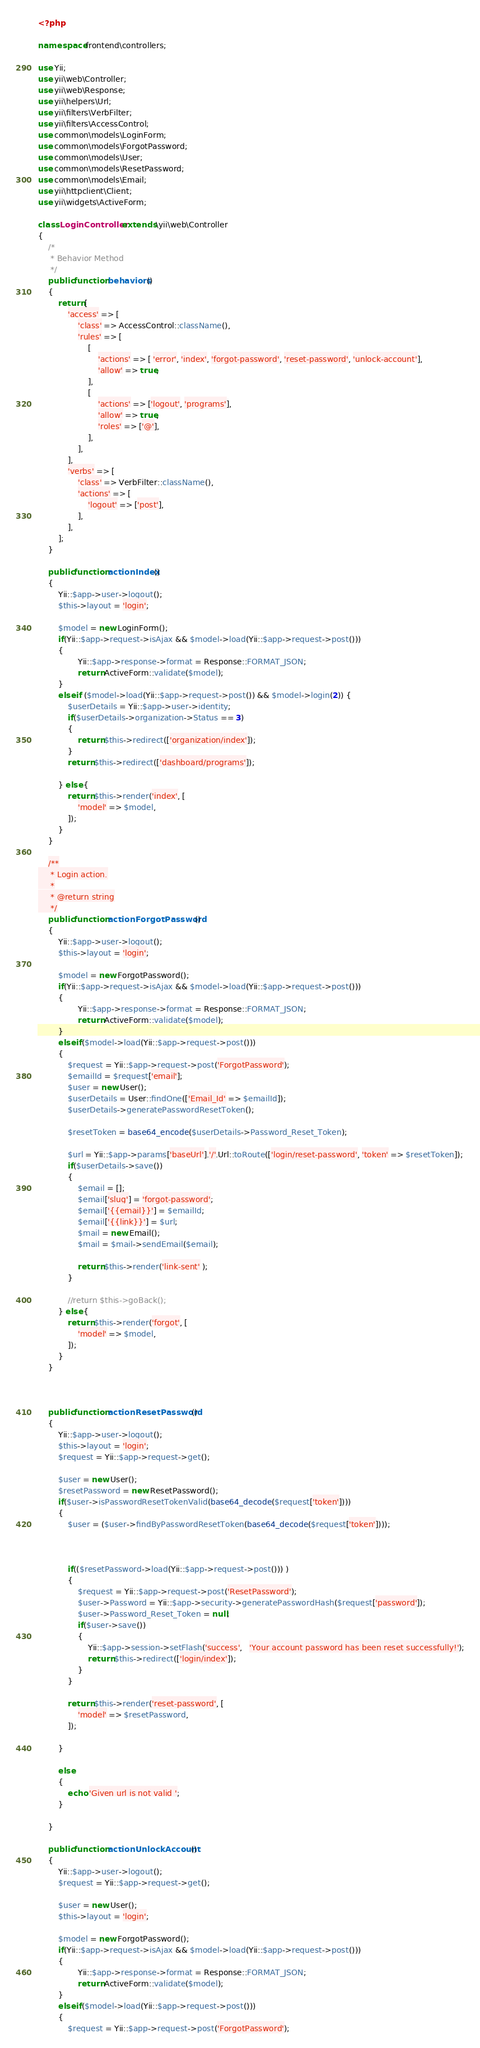Convert code to text. <code><loc_0><loc_0><loc_500><loc_500><_PHP_><?php

namespace frontend\controllers;

use Yii;
use yii\web\Controller;
use yii\web\Response;
use yii\helpers\Url;
use yii\filters\VerbFilter;
use yii\filters\AccessControl;
use common\models\LoginForm;
use common\models\ForgotPassword;
use common\models\User;
use common\models\ResetPassword;
use common\models\Email;
use yii\httpclient\Client;
use yii\widgets\ActiveForm;

class LoginController extends \yii\web\Controller
{
    /*
     * Behavior Method
     */
    public function behaviors()
    {
        return [
            'access' => [
                'class' => AccessControl::className(),
                'rules' => [
                    [
                        'actions' => [ 'error', 'index', 'forgot-password', 'reset-password', 'unlock-account'],
                        'allow' => true,
                    ],
                    [
                        'actions' => ['logout', 'programs'],
                        'allow' => true,
                        'roles' => ['@'],
                    ],
                ],
            ],
            'verbs' => [
                'class' => VerbFilter::className(),
                'actions' => [
                    'logout' => ['post'],
                ],
            ],
        ];
    }
    
    public function actionIndex()
    {
        Yii::$app->user->logout();
        $this->layout = 'login';
        
        $model = new LoginForm();
        if(Yii::$app->request->isAjax && $model->load(Yii::$app->request->post()))
        {
                Yii::$app->response->format = Response::FORMAT_JSON;
                return ActiveForm::validate($model);
        } 
        else if ($model->load(Yii::$app->request->post()) && $model->login(2)) {  
            $userDetails = Yii::$app->user->identity;
            if($userDetails->organization->Status == 3)
            {
                return $this->redirect(['organization/index']);
            }
            return $this->redirect(['dashboard/programs']);

        } else {
            return $this->render('index', [
                'model' => $model,
            ]);
        }
    }
    
    /**
     * Login action.
     *
     * @return string
     */
    public function actionForgotPassword()
    {
        Yii::$app->user->logout();
        $this->layout = 'login';
        
        $model = new ForgotPassword();
        if(Yii::$app->request->isAjax && $model->load(Yii::$app->request->post()))
        {
                Yii::$app->response->format = Response::FORMAT_JSON;
                return ActiveForm::validate($model);
        } 
        elseif ($model->load(Yii::$app->request->post())) 
        {
            $request = Yii::$app->request->post('ForgotPassword');
            $emailId = $request['email'];
            $user = new User();
            $userDetails = User::findOne(['Email_Id' => $emailId]);
            $userDetails->generatePasswordResetToken();
            
            $resetToken = base64_encode($userDetails->Password_Reset_Token);
            
            $url = Yii::$app->params['baseUrl'].'/'.Url::toRoute(['login/reset-password', 'token' => $resetToken]);
            if($userDetails->save())
            {
                $email = [];
                $email['slug'] = 'forgot-password';
                $email['{{email}}'] = $emailId;
                $email['{{link}}'] = $url;
                $mail = new Email();
                $mail = $mail->sendEmail($email);
                
                return $this->render('link-sent' );
            }
            
            //return $this->goBack();
        } else {
            return $this->render('forgot', [
                'model' => $model,
            ]);
        }
    }
    
    
    
    public function actionResetPassword()
    {
        Yii::$app->user->logout();
        $this->layout = 'login';
        $request = Yii::$app->request->get();
        
        $user = new User();
        $resetPassword = new ResetPassword();
        if($user->isPasswordResetTokenValid(base64_decode($request['token'])))
        {
            $user = ($user->findByPasswordResetToken(base64_decode($request['token'])));
            
            
            
            if(($resetPassword->load(Yii::$app->request->post())) )
            {
                $request = Yii::$app->request->post('ResetPassword');
                $user->Password = Yii::$app->security->generatePasswordHash($request['password']);
                $user->Password_Reset_Token = null;
                if($user->save())
                {
                    Yii::$app->session->setFlash('success',   'Your account password has been reset successfully!');
                    return $this->redirect(['login/index']);
                }
            }
            
            return $this->render('reset-password', [
                'model' => $resetPassword,
            ]);
            
        }
        
        else
        {
            echo 'Given url is not valid ';
        }
        
    }
    
    public function actionUnlockAccount()
    {
        Yii::$app->user->logout();
        $request = Yii::$app->request->get();
        
        $user = new User();
        $this->layout = 'login';
        
        $model = new ForgotPassword();
        if(Yii::$app->request->isAjax && $model->load(Yii::$app->request->post()))
        {
                Yii::$app->response->format = Response::FORMAT_JSON;
                return ActiveForm::validate($model);
        } 
        elseif ($model->load(Yii::$app->request->post())) 
        {
            $request = Yii::$app->request->post('ForgotPassword');</code> 